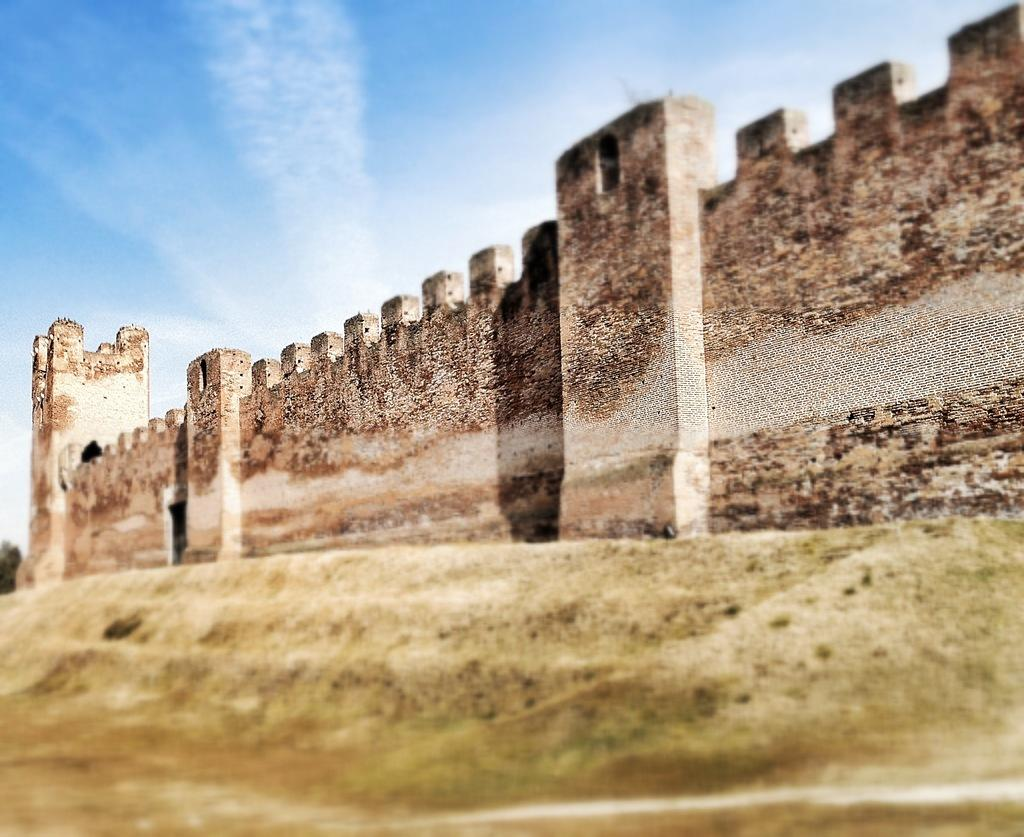What is visible at the bottom of the image? The ground is visible in the image. What structure can be seen in the image? There is a wall in the image. What colors are present on the wall? The wall is cream, black, and brown in color. What is visible in the background of the image? The sky and trees are visible in the background of the image. What color are the trees? The trees are green in color. What month is it in the image? The month cannot be determined from the image, as it does not contain any information about the time of year. 